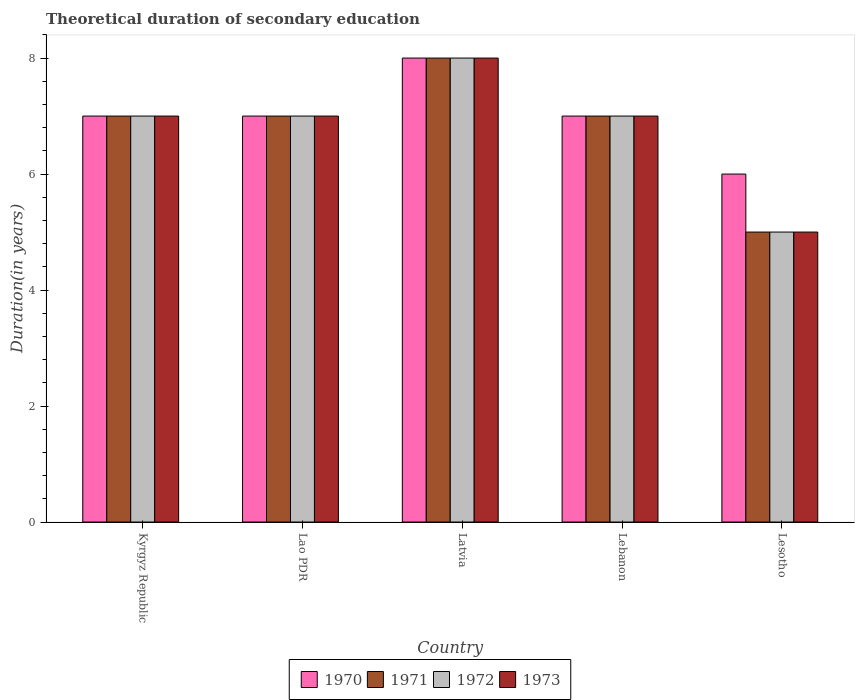How many groups of bars are there?
Ensure brevity in your answer.  5. Are the number of bars per tick equal to the number of legend labels?
Make the answer very short. Yes. Are the number of bars on each tick of the X-axis equal?
Make the answer very short. Yes. What is the label of the 2nd group of bars from the left?
Give a very brief answer. Lao PDR. In how many cases, is the number of bars for a given country not equal to the number of legend labels?
Provide a succinct answer. 0. What is the total theoretical duration of secondary education in 1971 in Lebanon?
Keep it short and to the point. 7. In which country was the total theoretical duration of secondary education in 1973 maximum?
Your response must be concise. Latvia. In which country was the total theoretical duration of secondary education in 1973 minimum?
Provide a succinct answer. Lesotho. What is the difference between the total theoretical duration of secondary education in 1973 in Latvia and that in Lebanon?
Give a very brief answer. 1. What is the difference between the total theoretical duration of secondary education in 1971 in Lebanon and the total theoretical duration of secondary education in 1973 in Kyrgyz Republic?
Keep it short and to the point. 0. What is the difference between the total theoretical duration of secondary education of/in 1971 and total theoretical duration of secondary education of/in 1973 in Kyrgyz Republic?
Ensure brevity in your answer.  0. In how many countries, is the total theoretical duration of secondary education in 1970 greater than 0.4 years?
Make the answer very short. 5. What is the ratio of the total theoretical duration of secondary education in 1973 in Kyrgyz Republic to that in Lebanon?
Provide a succinct answer. 1. Is the difference between the total theoretical duration of secondary education in 1971 in Latvia and Lebanon greater than the difference between the total theoretical duration of secondary education in 1973 in Latvia and Lebanon?
Ensure brevity in your answer.  No. In how many countries, is the total theoretical duration of secondary education in 1971 greater than the average total theoretical duration of secondary education in 1971 taken over all countries?
Keep it short and to the point. 4. What does the 1st bar from the left in Kyrgyz Republic represents?
Your response must be concise. 1970. What does the 3rd bar from the right in Latvia represents?
Give a very brief answer. 1971. Is it the case that in every country, the sum of the total theoretical duration of secondary education in 1970 and total theoretical duration of secondary education in 1973 is greater than the total theoretical duration of secondary education in 1971?
Your answer should be compact. Yes. How many bars are there?
Give a very brief answer. 20. How many countries are there in the graph?
Your response must be concise. 5. How are the legend labels stacked?
Offer a very short reply. Horizontal. What is the title of the graph?
Offer a terse response. Theoretical duration of secondary education. Does "1991" appear as one of the legend labels in the graph?
Provide a short and direct response. No. What is the label or title of the X-axis?
Your answer should be very brief. Country. What is the label or title of the Y-axis?
Give a very brief answer. Duration(in years). What is the Duration(in years) of 1970 in Kyrgyz Republic?
Your answer should be very brief. 7. What is the Duration(in years) in 1973 in Lao PDR?
Your response must be concise. 7. What is the Duration(in years) in 1972 in Latvia?
Provide a short and direct response. 8. What is the Duration(in years) in 1973 in Latvia?
Offer a very short reply. 8. What is the Duration(in years) of 1972 in Lebanon?
Give a very brief answer. 7. What is the Duration(in years) in 1970 in Lesotho?
Provide a succinct answer. 6. What is the Duration(in years) of 1972 in Lesotho?
Give a very brief answer. 5. Across all countries, what is the maximum Duration(in years) in 1972?
Offer a very short reply. 8. Across all countries, what is the minimum Duration(in years) of 1971?
Your answer should be compact. 5. Across all countries, what is the minimum Duration(in years) of 1972?
Keep it short and to the point. 5. What is the total Duration(in years) of 1971 in the graph?
Ensure brevity in your answer.  34. What is the total Duration(in years) in 1972 in the graph?
Offer a very short reply. 34. What is the total Duration(in years) of 1973 in the graph?
Keep it short and to the point. 34. What is the difference between the Duration(in years) in 1970 in Kyrgyz Republic and that in Lao PDR?
Your answer should be very brief. 0. What is the difference between the Duration(in years) of 1972 in Kyrgyz Republic and that in Lao PDR?
Offer a very short reply. 0. What is the difference between the Duration(in years) in 1973 in Kyrgyz Republic and that in Lao PDR?
Ensure brevity in your answer.  0. What is the difference between the Duration(in years) in 1971 in Kyrgyz Republic and that in Latvia?
Your answer should be very brief. -1. What is the difference between the Duration(in years) of 1971 in Kyrgyz Republic and that in Lebanon?
Your answer should be very brief. 0. What is the difference between the Duration(in years) in 1972 in Kyrgyz Republic and that in Lebanon?
Offer a terse response. 0. What is the difference between the Duration(in years) of 1970 in Kyrgyz Republic and that in Lesotho?
Provide a short and direct response. 1. What is the difference between the Duration(in years) in 1973 in Kyrgyz Republic and that in Lesotho?
Your answer should be very brief. 2. What is the difference between the Duration(in years) in 1972 in Lao PDR and that in Latvia?
Ensure brevity in your answer.  -1. What is the difference between the Duration(in years) in 1973 in Lao PDR and that in Latvia?
Offer a terse response. -1. What is the difference between the Duration(in years) of 1970 in Lao PDR and that in Lebanon?
Make the answer very short. 0. What is the difference between the Duration(in years) of 1972 in Lao PDR and that in Lebanon?
Keep it short and to the point. 0. What is the difference between the Duration(in years) of 1973 in Lao PDR and that in Lebanon?
Ensure brevity in your answer.  0. What is the difference between the Duration(in years) in 1970 in Lao PDR and that in Lesotho?
Make the answer very short. 1. What is the difference between the Duration(in years) of 1970 in Latvia and that in Lebanon?
Ensure brevity in your answer.  1. What is the difference between the Duration(in years) of 1971 in Latvia and that in Lebanon?
Provide a succinct answer. 1. What is the difference between the Duration(in years) in 1972 in Latvia and that in Lebanon?
Your answer should be very brief. 1. What is the difference between the Duration(in years) of 1970 in Latvia and that in Lesotho?
Your answer should be very brief. 2. What is the difference between the Duration(in years) in 1971 in Latvia and that in Lesotho?
Ensure brevity in your answer.  3. What is the difference between the Duration(in years) of 1972 in Latvia and that in Lesotho?
Provide a short and direct response. 3. What is the difference between the Duration(in years) in 1971 in Lebanon and that in Lesotho?
Make the answer very short. 2. What is the difference between the Duration(in years) of 1972 in Lebanon and that in Lesotho?
Make the answer very short. 2. What is the difference between the Duration(in years) of 1970 in Kyrgyz Republic and the Duration(in years) of 1972 in Lao PDR?
Your answer should be compact. 0. What is the difference between the Duration(in years) of 1970 in Kyrgyz Republic and the Duration(in years) of 1973 in Lao PDR?
Make the answer very short. 0. What is the difference between the Duration(in years) in 1970 in Kyrgyz Republic and the Duration(in years) in 1971 in Latvia?
Ensure brevity in your answer.  -1. What is the difference between the Duration(in years) in 1970 in Kyrgyz Republic and the Duration(in years) in 1973 in Latvia?
Ensure brevity in your answer.  -1. What is the difference between the Duration(in years) of 1971 in Kyrgyz Republic and the Duration(in years) of 1972 in Latvia?
Offer a terse response. -1. What is the difference between the Duration(in years) in 1972 in Kyrgyz Republic and the Duration(in years) in 1973 in Latvia?
Offer a terse response. -1. What is the difference between the Duration(in years) in 1970 in Kyrgyz Republic and the Duration(in years) in 1971 in Lebanon?
Make the answer very short. 0. What is the difference between the Duration(in years) of 1970 in Kyrgyz Republic and the Duration(in years) of 1972 in Lebanon?
Offer a terse response. 0. What is the difference between the Duration(in years) of 1970 in Kyrgyz Republic and the Duration(in years) of 1973 in Lebanon?
Offer a terse response. 0. What is the difference between the Duration(in years) in 1970 in Kyrgyz Republic and the Duration(in years) in 1971 in Lesotho?
Make the answer very short. 2. What is the difference between the Duration(in years) in 1970 in Kyrgyz Republic and the Duration(in years) in 1972 in Lesotho?
Your answer should be very brief. 2. What is the difference between the Duration(in years) of 1970 in Kyrgyz Republic and the Duration(in years) of 1973 in Lesotho?
Ensure brevity in your answer.  2. What is the difference between the Duration(in years) in 1971 in Kyrgyz Republic and the Duration(in years) in 1972 in Lesotho?
Give a very brief answer. 2. What is the difference between the Duration(in years) of 1971 in Kyrgyz Republic and the Duration(in years) of 1973 in Lesotho?
Offer a terse response. 2. What is the difference between the Duration(in years) of 1970 in Lao PDR and the Duration(in years) of 1971 in Latvia?
Make the answer very short. -1. What is the difference between the Duration(in years) in 1970 in Lao PDR and the Duration(in years) in 1972 in Latvia?
Give a very brief answer. -1. What is the difference between the Duration(in years) of 1970 in Lao PDR and the Duration(in years) of 1973 in Latvia?
Ensure brevity in your answer.  -1. What is the difference between the Duration(in years) of 1971 in Lao PDR and the Duration(in years) of 1972 in Latvia?
Provide a short and direct response. -1. What is the difference between the Duration(in years) in 1971 in Lao PDR and the Duration(in years) in 1973 in Latvia?
Ensure brevity in your answer.  -1. What is the difference between the Duration(in years) of 1970 in Lao PDR and the Duration(in years) of 1971 in Lebanon?
Give a very brief answer. 0. What is the difference between the Duration(in years) in 1970 in Lao PDR and the Duration(in years) in 1972 in Lebanon?
Ensure brevity in your answer.  0. What is the difference between the Duration(in years) of 1970 in Lao PDR and the Duration(in years) of 1973 in Lebanon?
Ensure brevity in your answer.  0. What is the difference between the Duration(in years) of 1972 in Lao PDR and the Duration(in years) of 1973 in Lebanon?
Your response must be concise. 0. What is the difference between the Duration(in years) of 1970 in Lao PDR and the Duration(in years) of 1971 in Lesotho?
Your answer should be compact. 2. What is the difference between the Duration(in years) of 1970 in Lao PDR and the Duration(in years) of 1972 in Lesotho?
Offer a very short reply. 2. What is the difference between the Duration(in years) of 1970 in Lao PDR and the Duration(in years) of 1973 in Lesotho?
Offer a terse response. 2. What is the difference between the Duration(in years) of 1971 in Lao PDR and the Duration(in years) of 1972 in Lesotho?
Provide a short and direct response. 2. What is the difference between the Duration(in years) of 1972 in Lao PDR and the Duration(in years) of 1973 in Lesotho?
Keep it short and to the point. 2. What is the difference between the Duration(in years) in 1970 in Latvia and the Duration(in years) in 1971 in Lebanon?
Your answer should be very brief. 1. What is the difference between the Duration(in years) of 1970 in Latvia and the Duration(in years) of 1972 in Lebanon?
Your answer should be very brief. 1. What is the difference between the Duration(in years) of 1970 in Latvia and the Duration(in years) of 1971 in Lesotho?
Offer a terse response. 3. What is the difference between the Duration(in years) in 1970 in Latvia and the Duration(in years) in 1972 in Lesotho?
Make the answer very short. 3. What is the difference between the Duration(in years) in 1971 in Latvia and the Duration(in years) in 1972 in Lesotho?
Your answer should be very brief. 3. What is the difference between the Duration(in years) in 1972 in Latvia and the Duration(in years) in 1973 in Lesotho?
Give a very brief answer. 3. What is the difference between the Duration(in years) in 1972 in Lebanon and the Duration(in years) in 1973 in Lesotho?
Make the answer very short. 2. What is the average Duration(in years) in 1970 per country?
Your answer should be very brief. 7. What is the average Duration(in years) in 1971 per country?
Make the answer very short. 6.8. What is the average Duration(in years) in 1972 per country?
Provide a short and direct response. 6.8. What is the difference between the Duration(in years) of 1970 and Duration(in years) of 1971 in Kyrgyz Republic?
Offer a very short reply. 0. What is the difference between the Duration(in years) in 1972 and Duration(in years) in 1973 in Kyrgyz Republic?
Offer a very short reply. 0. What is the difference between the Duration(in years) of 1970 and Duration(in years) of 1971 in Lao PDR?
Your answer should be compact. 0. What is the difference between the Duration(in years) in 1970 and Duration(in years) in 1972 in Lao PDR?
Make the answer very short. 0. What is the difference between the Duration(in years) in 1970 and Duration(in years) in 1973 in Lao PDR?
Your answer should be compact. 0. What is the difference between the Duration(in years) of 1971 and Duration(in years) of 1973 in Lao PDR?
Provide a succinct answer. 0. What is the difference between the Duration(in years) in 1970 and Duration(in years) in 1971 in Latvia?
Offer a terse response. 0. What is the difference between the Duration(in years) of 1970 and Duration(in years) of 1972 in Latvia?
Offer a terse response. 0. What is the difference between the Duration(in years) in 1971 and Duration(in years) in 1973 in Lebanon?
Provide a short and direct response. 0. What is the difference between the Duration(in years) of 1970 and Duration(in years) of 1971 in Lesotho?
Ensure brevity in your answer.  1. What is the difference between the Duration(in years) in 1970 and Duration(in years) in 1972 in Lesotho?
Keep it short and to the point. 1. What is the difference between the Duration(in years) of 1971 and Duration(in years) of 1972 in Lesotho?
Provide a short and direct response. 0. What is the difference between the Duration(in years) in 1971 and Duration(in years) in 1973 in Lesotho?
Give a very brief answer. 0. What is the ratio of the Duration(in years) of 1970 in Kyrgyz Republic to that in Lao PDR?
Offer a very short reply. 1. What is the ratio of the Duration(in years) of 1971 in Kyrgyz Republic to that in Lao PDR?
Ensure brevity in your answer.  1. What is the ratio of the Duration(in years) of 1973 in Kyrgyz Republic to that in Lao PDR?
Your response must be concise. 1. What is the ratio of the Duration(in years) in 1970 in Kyrgyz Republic to that in Latvia?
Provide a succinct answer. 0.88. What is the ratio of the Duration(in years) of 1971 in Kyrgyz Republic to that in Latvia?
Offer a very short reply. 0.88. What is the ratio of the Duration(in years) of 1973 in Kyrgyz Republic to that in Latvia?
Provide a short and direct response. 0.88. What is the ratio of the Duration(in years) in 1970 in Kyrgyz Republic to that in Lebanon?
Provide a short and direct response. 1. What is the ratio of the Duration(in years) of 1971 in Kyrgyz Republic to that in Lebanon?
Offer a very short reply. 1. What is the ratio of the Duration(in years) of 1972 in Kyrgyz Republic to that in Lebanon?
Offer a very short reply. 1. What is the ratio of the Duration(in years) in 1972 in Kyrgyz Republic to that in Lesotho?
Provide a succinct answer. 1.4. What is the ratio of the Duration(in years) of 1971 in Lao PDR to that in Latvia?
Provide a succinct answer. 0.88. What is the ratio of the Duration(in years) in 1970 in Lao PDR to that in Lebanon?
Provide a succinct answer. 1. What is the ratio of the Duration(in years) in 1971 in Lao PDR to that in Lebanon?
Ensure brevity in your answer.  1. What is the ratio of the Duration(in years) in 1972 in Lao PDR to that in Lebanon?
Your response must be concise. 1. What is the ratio of the Duration(in years) of 1970 in Lao PDR to that in Lesotho?
Keep it short and to the point. 1.17. What is the ratio of the Duration(in years) in 1972 in Lao PDR to that in Lesotho?
Your answer should be compact. 1.4. What is the ratio of the Duration(in years) in 1973 in Lao PDR to that in Lesotho?
Offer a terse response. 1.4. What is the ratio of the Duration(in years) of 1971 in Latvia to that in Lebanon?
Make the answer very short. 1.14. What is the ratio of the Duration(in years) in 1973 in Latvia to that in Lebanon?
Ensure brevity in your answer.  1.14. What is the ratio of the Duration(in years) of 1970 in Latvia to that in Lesotho?
Offer a terse response. 1.33. What is the ratio of the Duration(in years) in 1971 in Latvia to that in Lesotho?
Give a very brief answer. 1.6. What is the ratio of the Duration(in years) of 1973 in Latvia to that in Lesotho?
Provide a short and direct response. 1.6. What is the ratio of the Duration(in years) in 1970 in Lebanon to that in Lesotho?
Offer a terse response. 1.17. What is the ratio of the Duration(in years) in 1973 in Lebanon to that in Lesotho?
Offer a terse response. 1.4. What is the difference between the highest and the second highest Duration(in years) in 1970?
Your response must be concise. 1. What is the difference between the highest and the second highest Duration(in years) in 1971?
Offer a very short reply. 1. What is the difference between the highest and the second highest Duration(in years) of 1972?
Keep it short and to the point. 1. What is the difference between the highest and the second highest Duration(in years) of 1973?
Your answer should be very brief. 1. What is the difference between the highest and the lowest Duration(in years) in 1971?
Your answer should be compact. 3. What is the difference between the highest and the lowest Duration(in years) in 1972?
Provide a short and direct response. 3. What is the difference between the highest and the lowest Duration(in years) in 1973?
Your response must be concise. 3. 